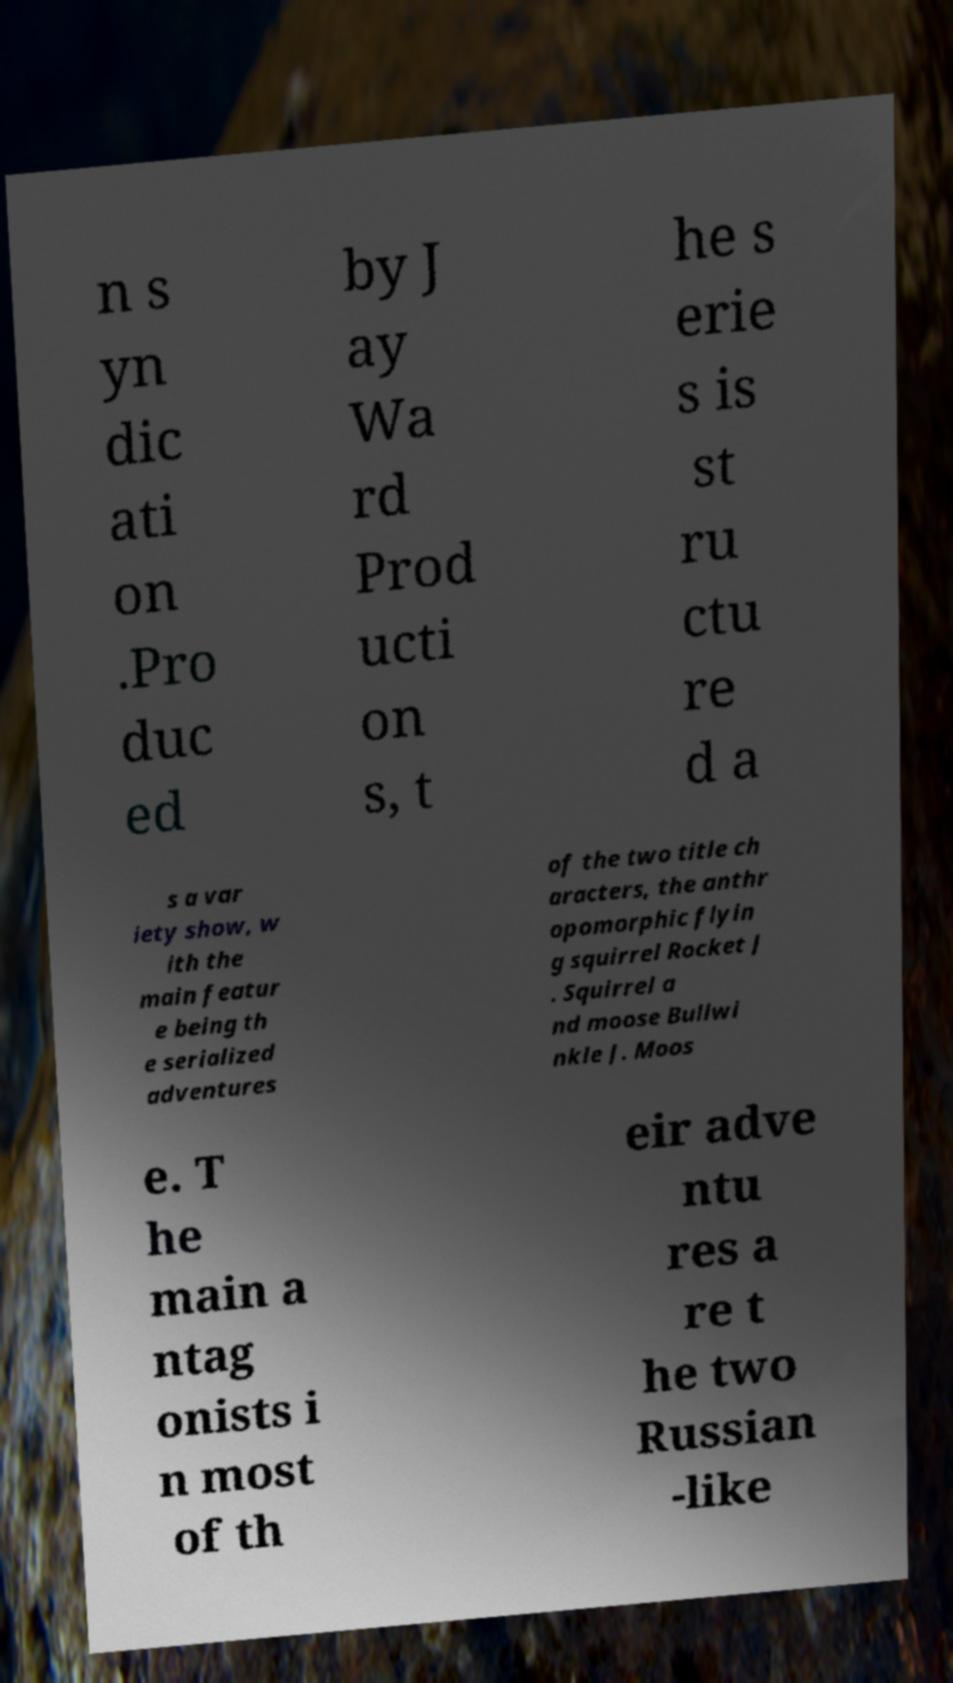Could you assist in decoding the text presented in this image and type it out clearly? n s yn dic ati on .Pro duc ed by J ay Wa rd Prod ucti on s, t he s erie s is st ru ctu re d a s a var iety show, w ith the main featur e being th e serialized adventures of the two title ch aracters, the anthr opomorphic flyin g squirrel Rocket J . Squirrel a nd moose Bullwi nkle J. Moos e. T he main a ntag onists i n most of th eir adve ntu res a re t he two Russian -like 